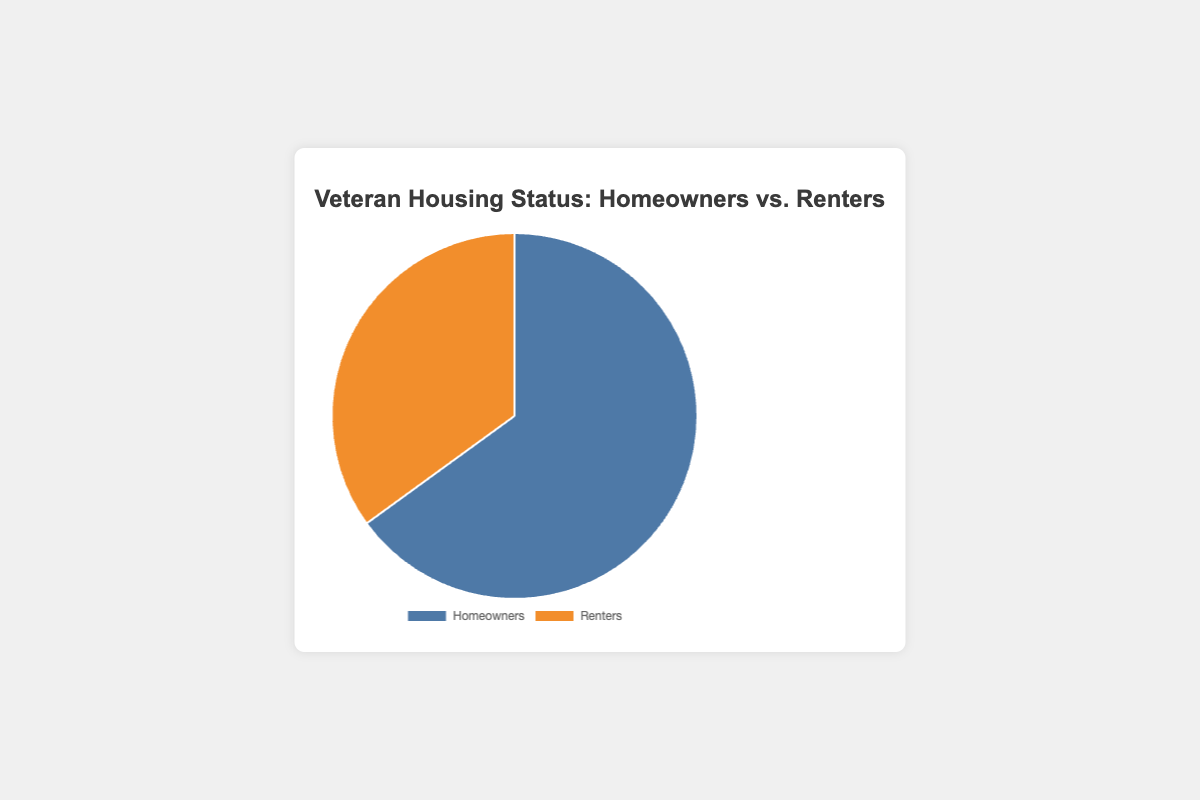What percentage of veterans are homeowners? The pie chart shows a 65% portion for homeowners.
Answer: 65% What percentage of veterans are renters? The pie chart shows a 35% portion for renters.
Answer: 35% Which housing status has a higher percentage of veterans? Comparing the two sections of the pie chart, the homeowner section (65%) is larger than the renter section (35%).
Answer: Homeowners By how much percentage does the veteran homeowner population exceed the renter population? Subtract the percentage of renters (35%) from the percentage of homeowners (65%). 65% - 35% = 30%
Answer: 30% If you combine the percentages of homeowners and renters, what total percentage do you get? Add the two percentages provided in the pie chart: 65% (homeowners) + 35% (renters) = 100%
Answer: 100% What color represents the veterans who are renters in the chart? The pie chart section for renters is colored in orange.
Answer: Orange How many times larger is the percentage of veteran homeowners compared to renters? Divide the percentage of homeowners (65%) by the percentage of renters (35%): 65 / 35 ≈ 1.857. So, the homeowners' percentage is approximately 1.86 times larger than that of renters.
Answer: 1.86 Given the total veteran population, if 1000 veterans are renters, how many would be homeowners? First, find the homeowner-to-renter ratio which is 65/35 = 1.857. Therefore, if 1000 veterans are renters, then the number of homeowners = 1000 * 1.857 ≈ 1857 veterans.
Answer: 1857 veterans What is the sum of the percentages of veterans who are homeowners and those who are renters? Adding the percentages of homeowners (65%) and renters (35%) gives: 65% + 35% = 100%
Answer: 100% 